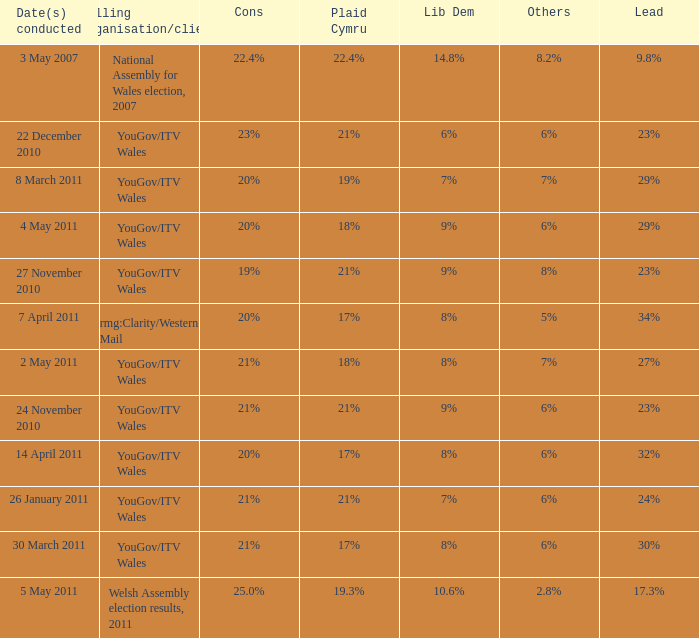I want the lead for others being 5% 34%. 